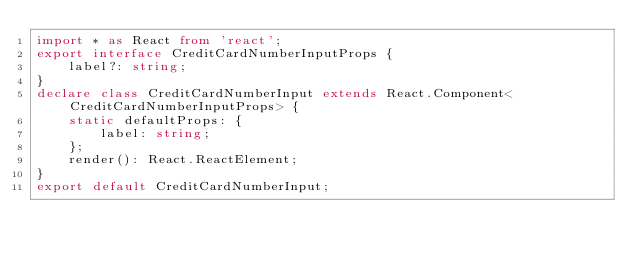<code> <loc_0><loc_0><loc_500><loc_500><_TypeScript_>import * as React from 'react';
export interface CreditCardNumberInputProps {
    label?: string;
}
declare class CreditCardNumberInput extends React.Component<CreditCardNumberInputProps> {
    static defaultProps: {
        label: string;
    };
    render(): React.ReactElement;
}
export default CreditCardNumberInput;
</code> 